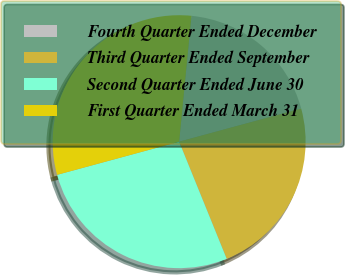<chart> <loc_0><loc_0><loc_500><loc_500><pie_chart><fcel>Fourth Quarter Ended December<fcel>Third Quarter Ended September<fcel>Second Quarter Ended June 30<fcel>First Quarter Ended March 31<nl><fcel>19.23%<fcel>23.08%<fcel>26.92%<fcel>30.77%<nl></chart> 